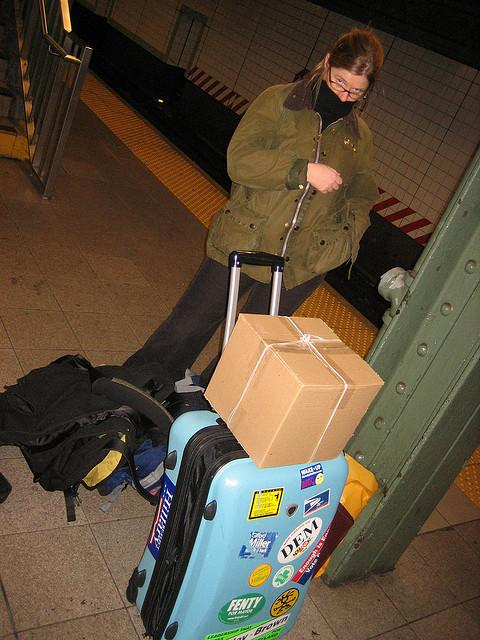What type of area is the woman waiting in?

Choices:
A) lobby
B) hotel
C) subway
D) bus stop subway 